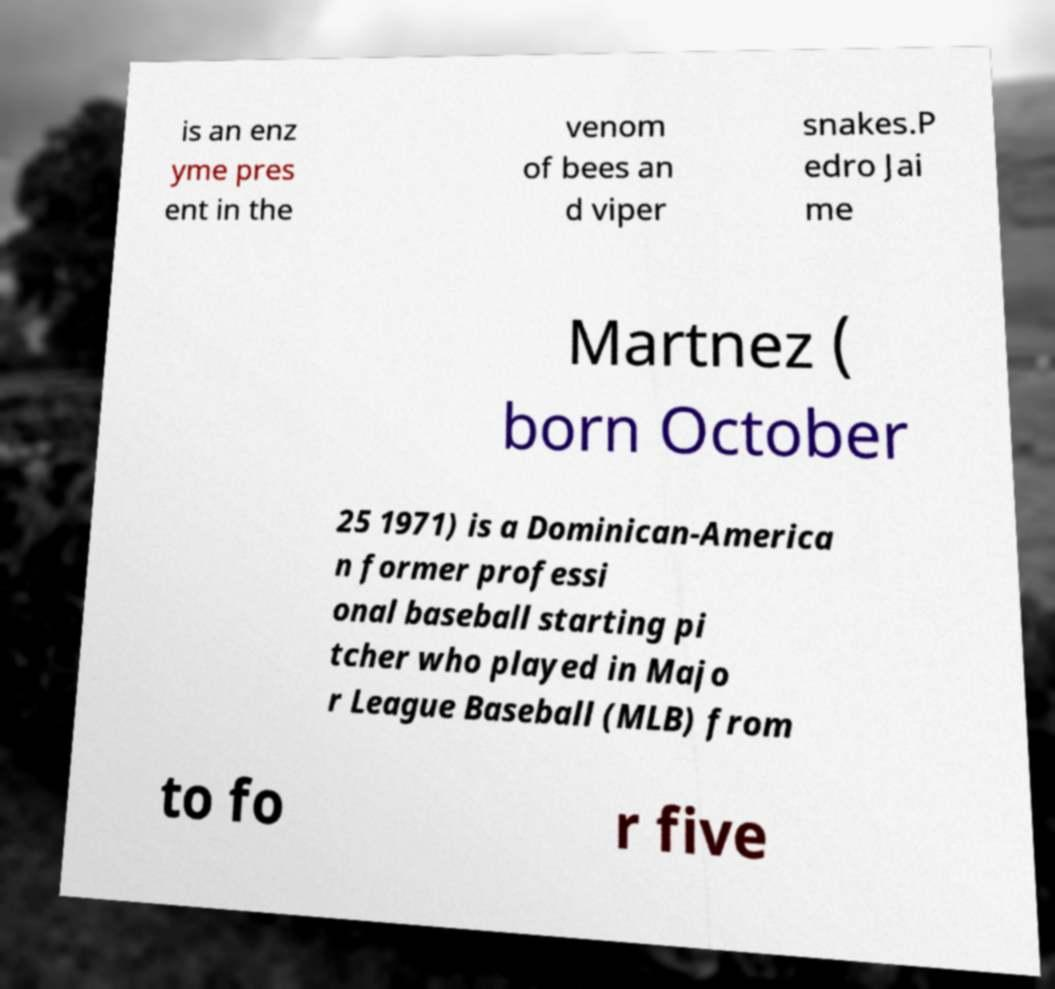Could you extract and type out the text from this image? is an enz yme pres ent in the venom of bees an d viper snakes.P edro Jai me Martnez ( born October 25 1971) is a Dominican-America n former professi onal baseball starting pi tcher who played in Majo r League Baseball (MLB) from to fo r five 